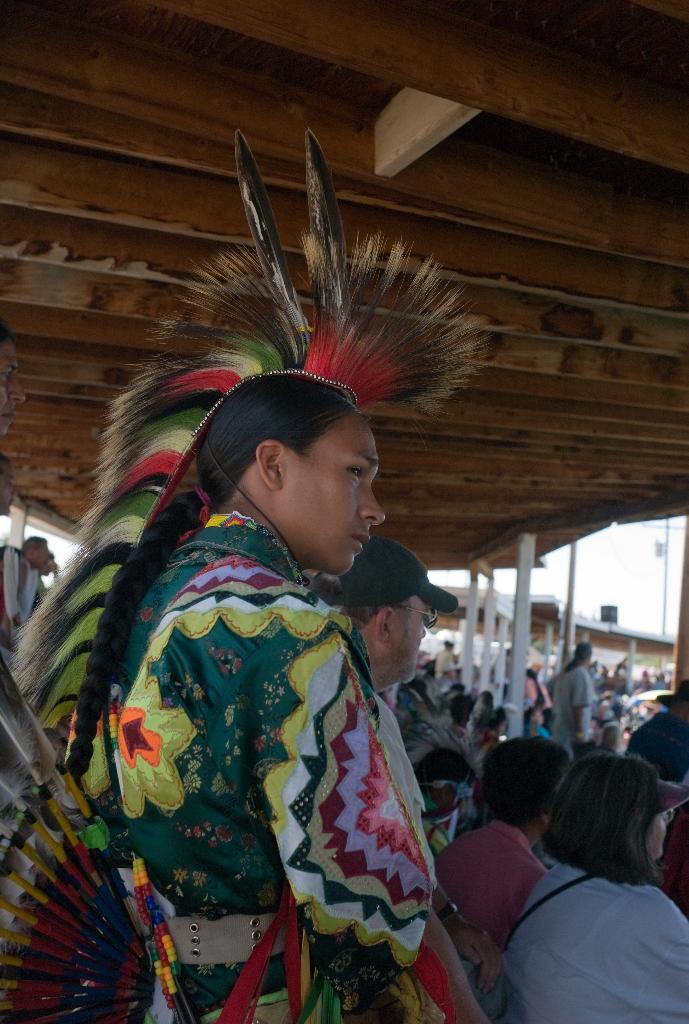What is the main subject of the image? There is a person standing in the image. What is the person wearing? The person is wearing a costume. What can be seen in the background of the image? In the background of the image, there are people sitting on chairs. What part of the room can be seen above the subjects in the image? There is a ceiling visible in the image. What type of degree does the person in the costume hold? There is no information about the person's degree in the image. What scent can be detected in the image? There is no mention of any scent in the image. 